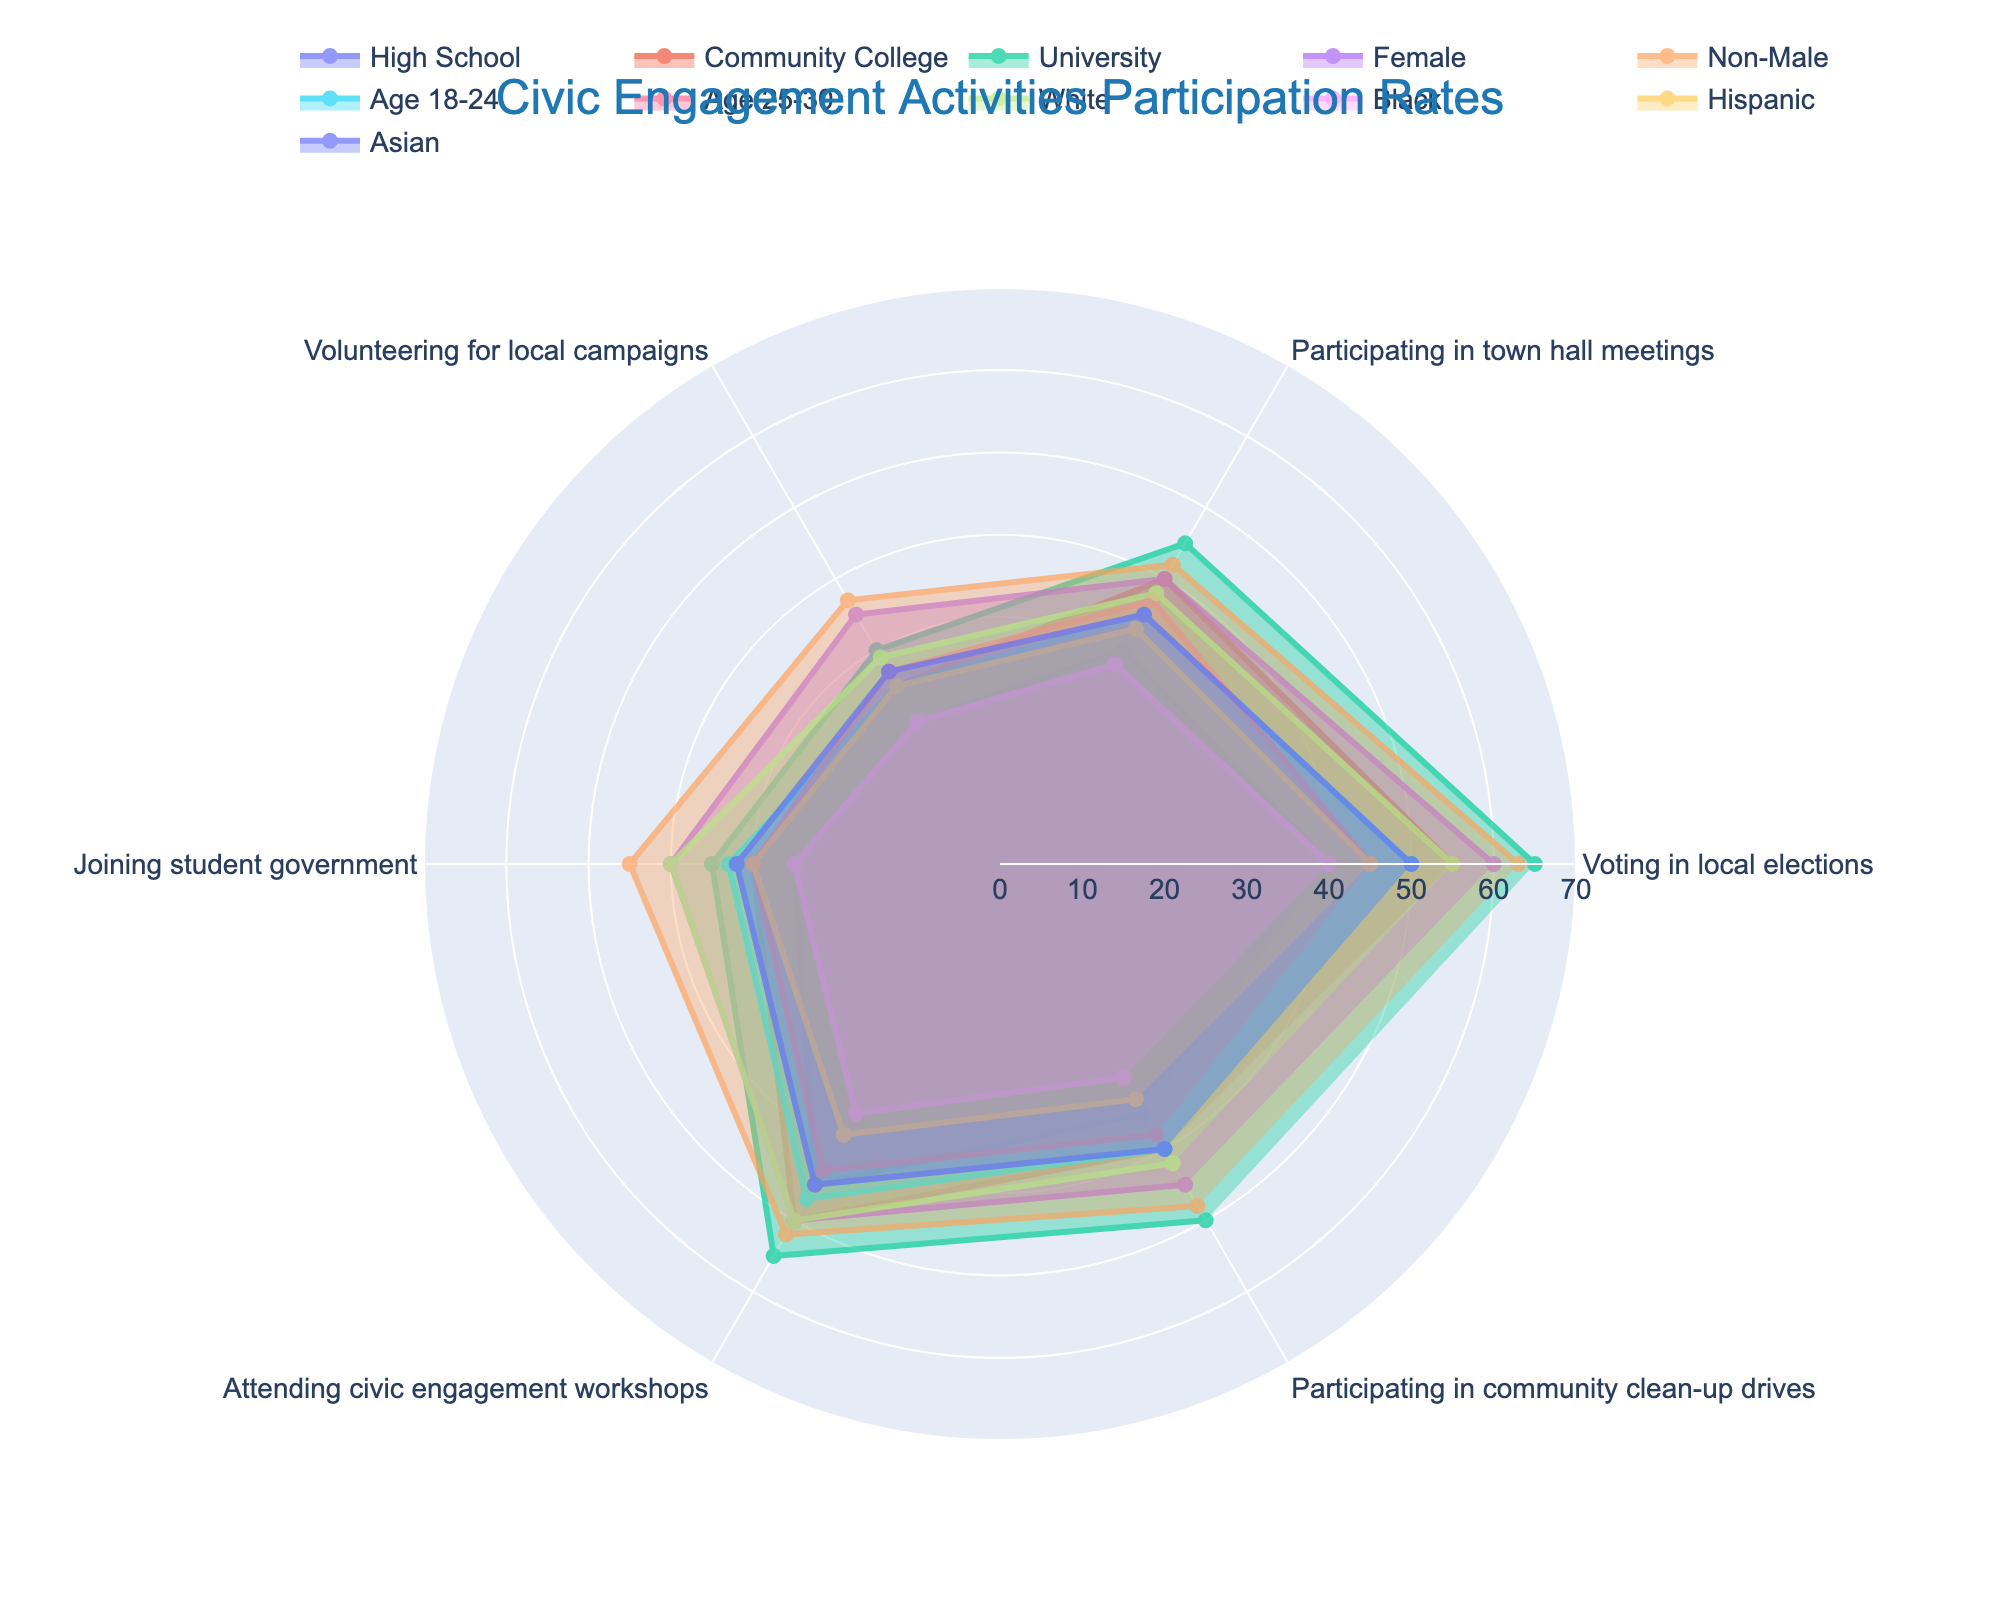What is the title of the radar chart? The title is typically placed at the top of the chart and provides a summary of what the chart represents.
Answer: Civic Engagement Activities Participation Rates Which group has the highest participation rate in Voting in local elections? By looking at the data points corresponding to 'Voting in local elections,' we can see which group has the highest rate.
Answer: University What is the difference in participation rate for Attending civic engagement workshops between Female and Age 18-24 groups? For Attending civic engagement workshops, note the rates for Female (50) and Age 18-24 (47). The difference is 50 - 47.
Answer: 3 Which Civic Engagement Activity has the lowest participation rate for the High School group? By comparing the values for each activity under the High School column, the lowest value is for Volunteering for local campaigns.
Answer: Volunteering for local campaigns Compare the participation rates in Participating in community clean-up drives between White and Hispanic groups. For Participating in community clean-up drives, note the rates for White (42) and Hispanic (33). Since 42 is greater than 33, the White group has a higher rate.
Answer: White Calculate the average participation rate in Participating in town hall meetings across all groups. Sum the participation rates for each group under this category and divide by the number of groups. (30+40+45+40+42+35+37+38+28+33+35) / 11 ≈ 36.18.
Answer: 36.18 Which gender group has a higher participation rate in Joining student government, and by how much? For Joining student government, compare rates for Female (40) and Non-Male (45). The Non-Male group has a higher rate. The difference is 45 - 40.
Answer: Non-Male, 5 What is the range of participation rates for Participating in community clean-up drives for all groups? The highest value is 50 (University), and the lowest is 30 (Black). Therefore, the range is 50 - 30.
Answer: 20 Which age group has a higher participation rate in Volunteering for local campaigns, and by how much? Compare Age 18-24 (25) and Age 25-30 (27) for this activity. Age 25-30 has a higher rate. The difference is 27 - 25.
Answer: Age 25-30, 2 Which racial group has the highest average participation rate across all activities? Calculate the average participation rates for White, Black, Hispanic, and Asian groups by summing values for each and dividing by the number of activities. Hispanic: (45+33+25+30+38+33)/6 ≈ 34, Asian: (50+35+27+32+45+40)/6 ≈ 38.17, Black: (40+28+20+25+35+30)/6 ≈ 29.67, White: (55+38+29+40+50+42)/6 ≈ 42.33. White has the highest average.
Answer: White 